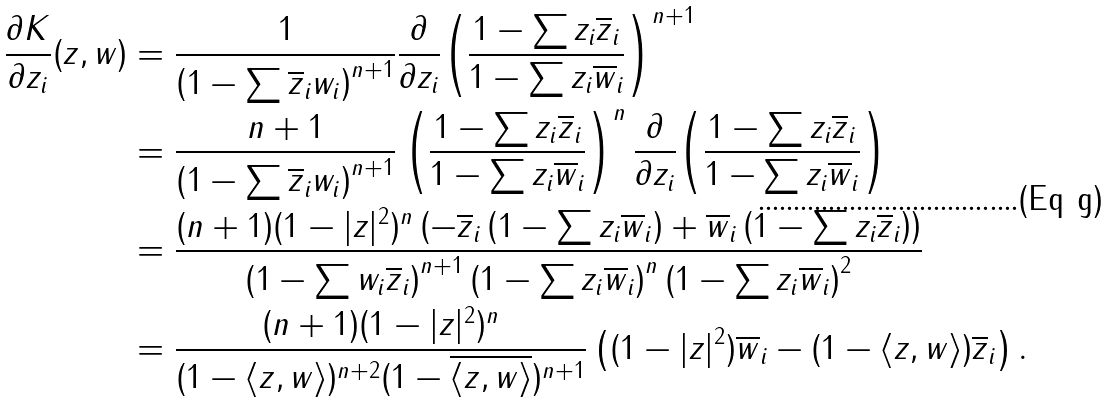Convert formula to latex. <formula><loc_0><loc_0><loc_500><loc_500>\frac { \partial K } { \partial z _ { i } } ( z , w ) & = \frac { 1 } { \left ( 1 - \sum \overline { z } _ { i } w _ { i } \right ) ^ { n + 1 } } \frac { \partial } { \partial z _ { i } } { \left ( \frac { 1 - \sum { z _ { i } \overline { z } _ { i } } } { 1 - \sum { z _ { i } \overline { w } _ { i } } } \right ) ^ { n + 1 } } \\ & = \frac { n + 1 } { \left ( 1 - \sum { \overline { z } _ { i } w _ { i } } \right ) ^ { n + 1 } } \left ( \frac { 1 - \sum { z _ { i } \overline { z } _ { i } } } { 1 - \sum { z _ { i } \overline { w } _ { i } } } \right ) ^ { n } \frac { \partial } { \partial z _ { i } } { \left ( \frac { 1 - \sum { z _ { i } \overline { z } _ { i } } } { 1 - \sum { z _ { i } \overline { w } _ { i } } } \right ) } \\ & = \frac { ( n + 1 ) ( 1 - | z | ^ { 2 } ) ^ { n } \left ( - \overline { z } _ { i } \left ( 1 - \sum { z _ { i } \overline { w } _ { i } } \right ) + \overline { w } _ { i } \left ( 1 - \sum { z _ { i } \overline { z } _ { i } } \right ) \right ) } { \left ( 1 - \sum { w _ { i } \overline { z } _ { i } } \right ) ^ { n + 1 } \left ( 1 - \sum { z _ { i } \overline { w } _ { i } } \right ) ^ { n } \left ( 1 - \sum { z _ { i } \overline { w } _ { i } } \right ) ^ { 2 } } \\ & = \frac { ( n + 1 ) ( 1 - | z | ^ { 2 } ) ^ { n } } { ( 1 - \langle z , w \rangle ) ^ { n + 2 } ( 1 - \overline { \langle z , w \rangle } ) ^ { n + 1 } } \left ( ( 1 - | z | ^ { 2 } ) \overline { w } _ { i } - ( 1 - \langle z , w \rangle ) \overline { z } _ { i } \right ) .</formula> 